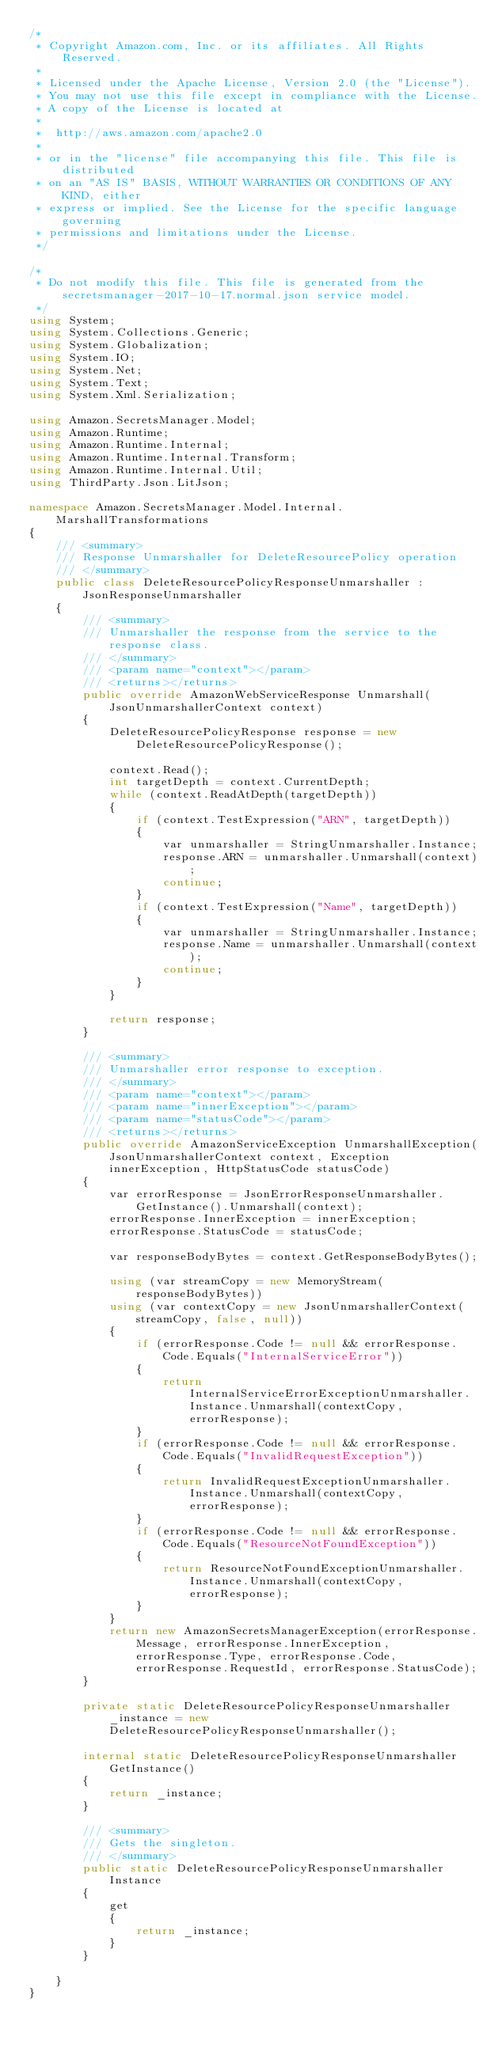Convert code to text. <code><loc_0><loc_0><loc_500><loc_500><_C#_>/*
 * Copyright Amazon.com, Inc. or its affiliates. All Rights Reserved.
 * 
 * Licensed under the Apache License, Version 2.0 (the "License").
 * You may not use this file except in compliance with the License.
 * A copy of the License is located at
 * 
 *  http://aws.amazon.com/apache2.0
 * 
 * or in the "license" file accompanying this file. This file is distributed
 * on an "AS IS" BASIS, WITHOUT WARRANTIES OR CONDITIONS OF ANY KIND, either
 * express or implied. See the License for the specific language governing
 * permissions and limitations under the License.
 */

/*
 * Do not modify this file. This file is generated from the secretsmanager-2017-10-17.normal.json service model.
 */
using System;
using System.Collections.Generic;
using System.Globalization;
using System.IO;
using System.Net;
using System.Text;
using System.Xml.Serialization;

using Amazon.SecretsManager.Model;
using Amazon.Runtime;
using Amazon.Runtime.Internal;
using Amazon.Runtime.Internal.Transform;
using Amazon.Runtime.Internal.Util;
using ThirdParty.Json.LitJson;

namespace Amazon.SecretsManager.Model.Internal.MarshallTransformations
{
    /// <summary>
    /// Response Unmarshaller for DeleteResourcePolicy operation
    /// </summary>  
    public class DeleteResourcePolicyResponseUnmarshaller : JsonResponseUnmarshaller
    {
        /// <summary>
        /// Unmarshaller the response from the service to the response class.
        /// </summary>  
        /// <param name="context"></param>
        /// <returns></returns>
        public override AmazonWebServiceResponse Unmarshall(JsonUnmarshallerContext context)
        {
            DeleteResourcePolicyResponse response = new DeleteResourcePolicyResponse();

            context.Read();
            int targetDepth = context.CurrentDepth;
            while (context.ReadAtDepth(targetDepth))
            {
                if (context.TestExpression("ARN", targetDepth))
                {
                    var unmarshaller = StringUnmarshaller.Instance;
                    response.ARN = unmarshaller.Unmarshall(context);
                    continue;
                }
                if (context.TestExpression("Name", targetDepth))
                {
                    var unmarshaller = StringUnmarshaller.Instance;
                    response.Name = unmarshaller.Unmarshall(context);
                    continue;
                }
            }

            return response;
        }

        /// <summary>
        /// Unmarshaller error response to exception.
        /// </summary>  
        /// <param name="context"></param>
        /// <param name="innerException"></param>
        /// <param name="statusCode"></param>
        /// <returns></returns>
        public override AmazonServiceException UnmarshallException(JsonUnmarshallerContext context, Exception innerException, HttpStatusCode statusCode)
        {
            var errorResponse = JsonErrorResponseUnmarshaller.GetInstance().Unmarshall(context);
            errorResponse.InnerException = innerException;
            errorResponse.StatusCode = statusCode;

            var responseBodyBytes = context.GetResponseBodyBytes();

            using (var streamCopy = new MemoryStream(responseBodyBytes))
            using (var contextCopy = new JsonUnmarshallerContext(streamCopy, false, null))
            {
                if (errorResponse.Code != null && errorResponse.Code.Equals("InternalServiceError"))
                {
                    return InternalServiceErrorExceptionUnmarshaller.Instance.Unmarshall(contextCopy, errorResponse);
                }
                if (errorResponse.Code != null && errorResponse.Code.Equals("InvalidRequestException"))
                {
                    return InvalidRequestExceptionUnmarshaller.Instance.Unmarshall(contextCopy, errorResponse);
                }
                if (errorResponse.Code != null && errorResponse.Code.Equals("ResourceNotFoundException"))
                {
                    return ResourceNotFoundExceptionUnmarshaller.Instance.Unmarshall(contextCopy, errorResponse);
                }
            }
            return new AmazonSecretsManagerException(errorResponse.Message, errorResponse.InnerException, errorResponse.Type, errorResponse.Code, errorResponse.RequestId, errorResponse.StatusCode);
        }

        private static DeleteResourcePolicyResponseUnmarshaller _instance = new DeleteResourcePolicyResponseUnmarshaller();        

        internal static DeleteResourcePolicyResponseUnmarshaller GetInstance()
        {
            return _instance;
        }

        /// <summary>
        /// Gets the singleton.
        /// </summary>  
        public static DeleteResourcePolicyResponseUnmarshaller Instance
        {
            get
            {
                return _instance;
            }
        }

    }
}</code> 